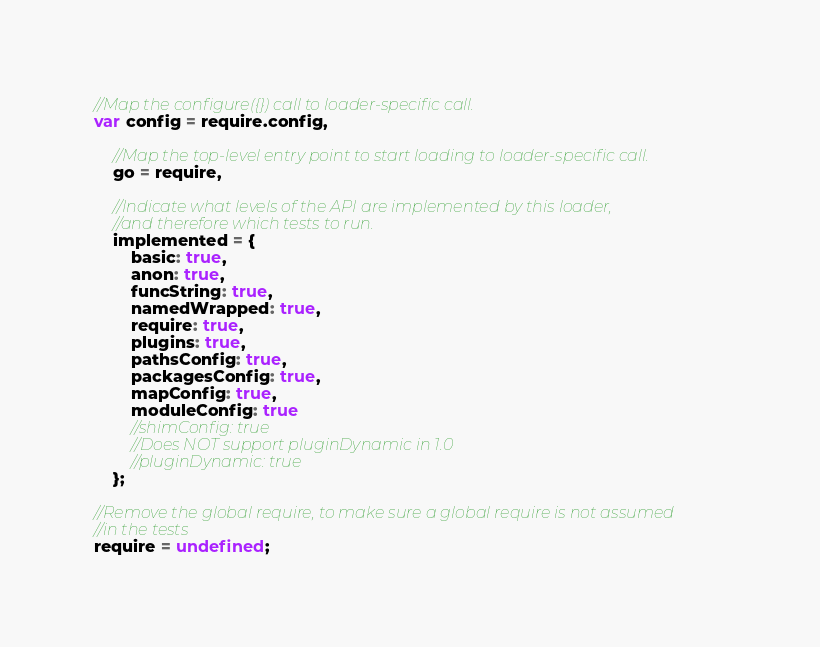<code> <loc_0><loc_0><loc_500><loc_500><_JavaScript_>
//Map the configure({}) call to loader-specific call.
var config = require.config,

    //Map the top-level entry point to start loading to loader-specific call.
    go = require,

    //Indicate what levels of the API are implemented by this loader,
    //and therefore which tests to run.
    implemented = {
        basic: true,
        anon: true,
        funcString: true,
        namedWrapped: true,
        require: true,
        plugins: true,
        pathsConfig: true,
        packagesConfig: true,
        mapConfig: true,
        moduleConfig: true
        //shimConfig: true
        //Does NOT support pluginDynamic in 1.0
        //pluginDynamic: true
    };

//Remove the global require, to make sure a global require is not assumed
//in the tests
require = undefined;
</code> 